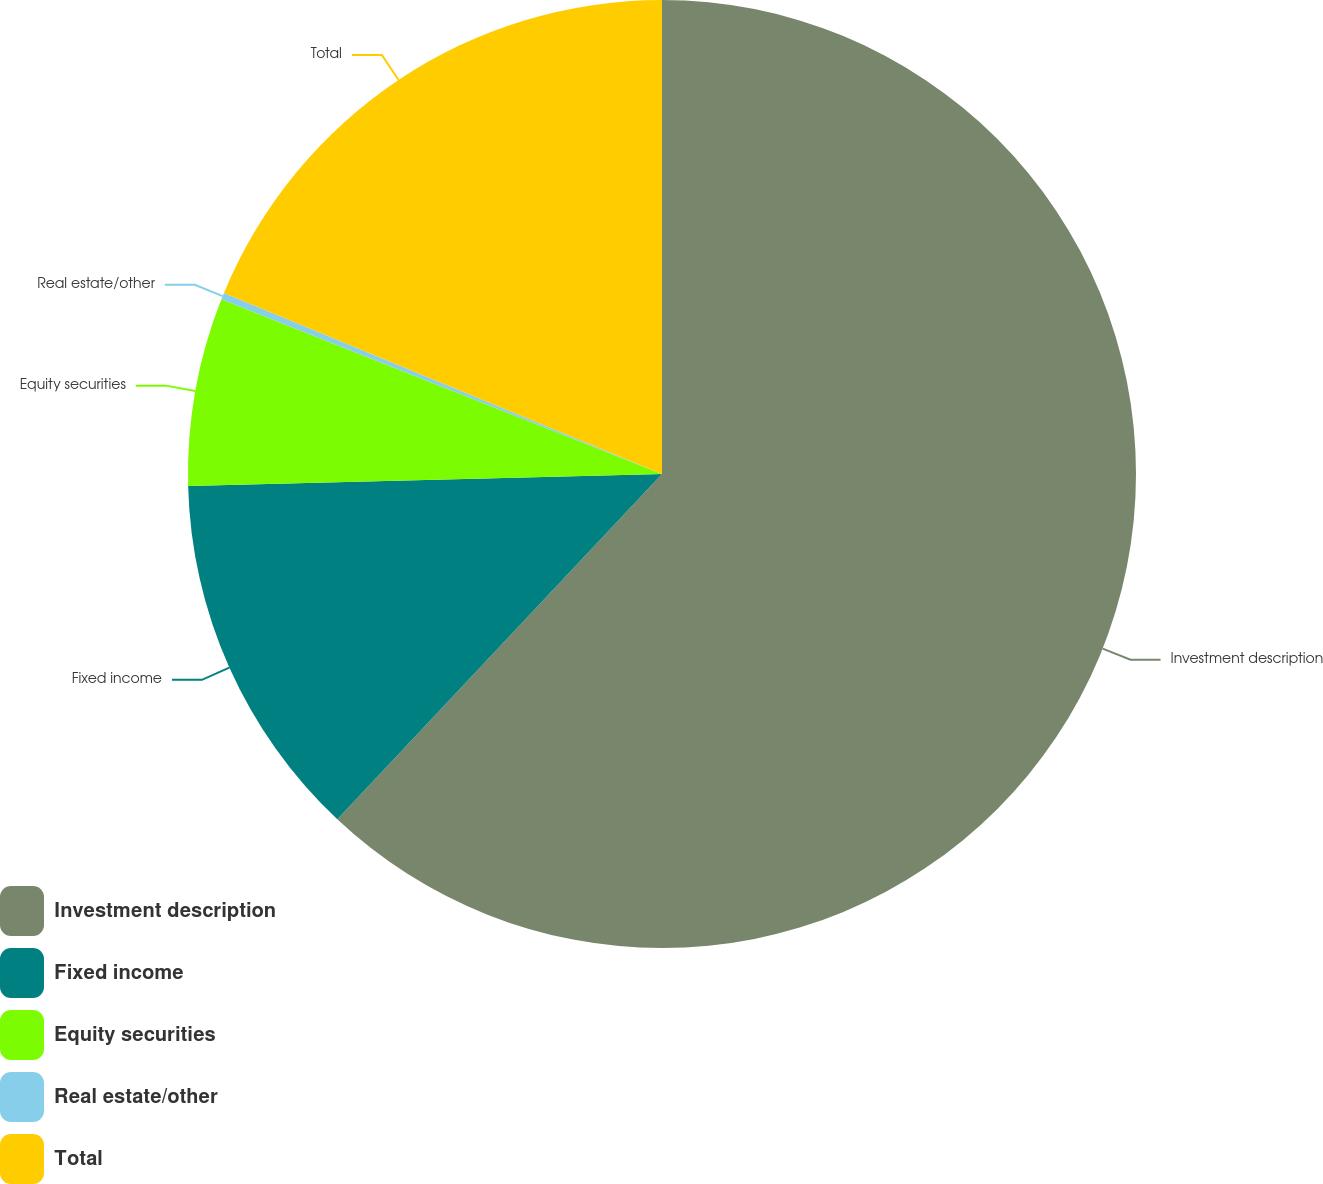<chart> <loc_0><loc_0><loc_500><loc_500><pie_chart><fcel>Investment description<fcel>Fixed income<fcel>Equity securities<fcel>Real estate/other<fcel>Total<nl><fcel>62.01%<fcel>12.59%<fcel>6.41%<fcel>0.23%<fcel>18.76%<nl></chart> 